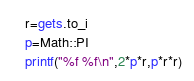Convert code to text. <code><loc_0><loc_0><loc_500><loc_500><_Ruby_>r=gets.to_i
p=Math::PI
printf("%f %f\n",2*p*r,p*r*r)
</code> 